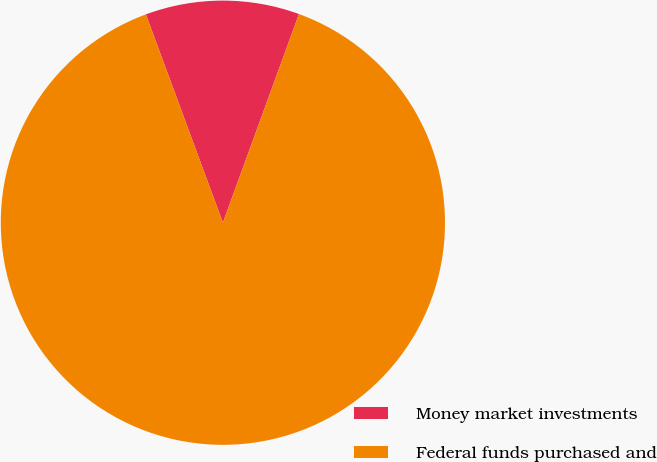<chart> <loc_0><loc_0><loc_500><loc_500><pie_chart><fcel>Money market investments<fcel>Federal funds purchased and<nl><fcel>11.2%<fcel>88.8%<nl></chart> 